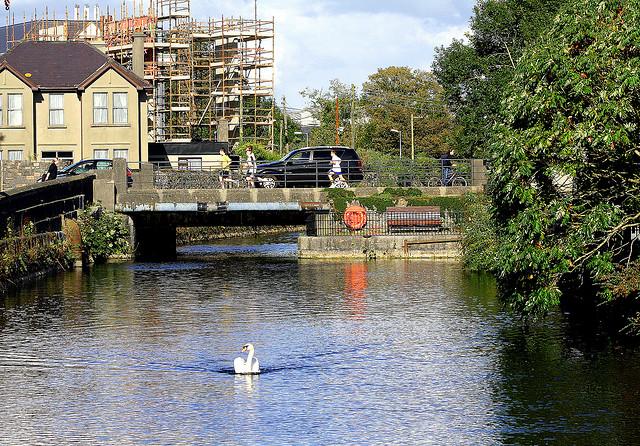Are there people walking across the bridge?
Quick response, please. Yes. How many people are in the water?
Be succinct. 0. Are there boats in this picture?
Give a very brief answer. No. What is in the water?
Give a very brief answer. Swan. 